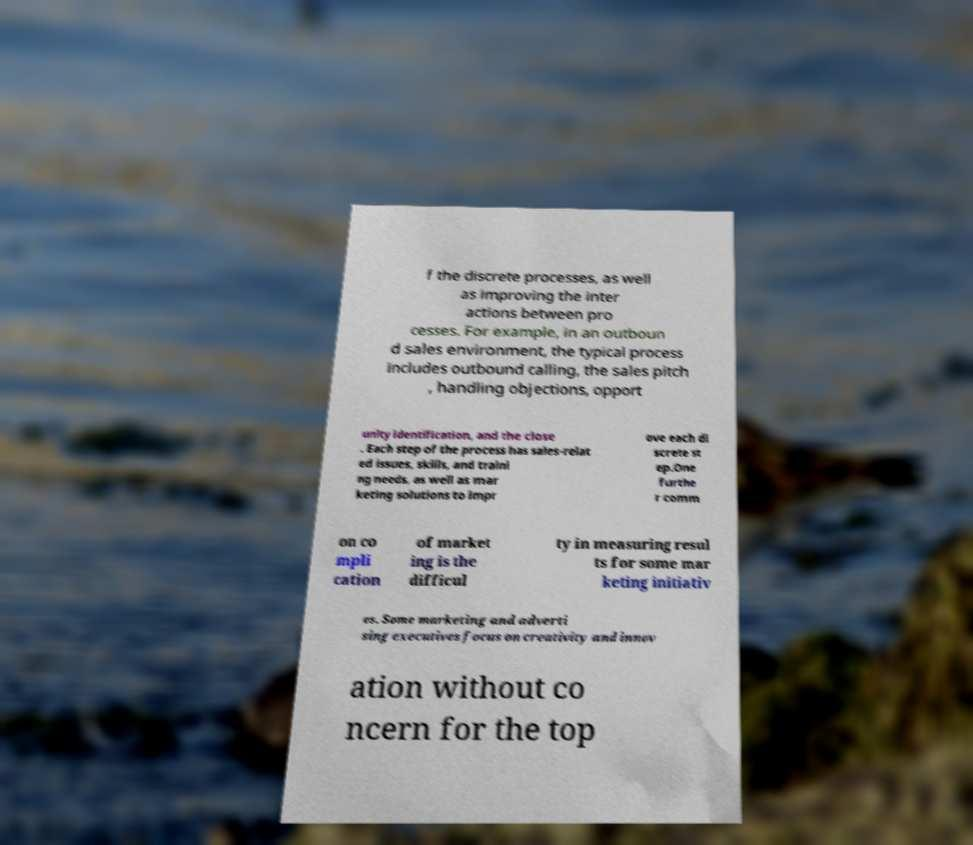Please read and relay the text visible in this image. What does it say? f the discrete processes, as well as improving the inter actions between pro cesses. For example, in an outboun d sales environment, the typical process includes outbound calling, the sales pitch , handling objections, opport unity identification, and the close . Each step of the process has sales-relat ed issues, skills, and traini ng needs, as well as mar keting solutions to impr ove each di screte st ep.One furthe r comm on co mpli cation of market ing is the difficul ty in measuring resul ts for some mar keting initiativ es. Some marketing and adverti sing executives focus on creativity and innov ation without co ncern for the top 